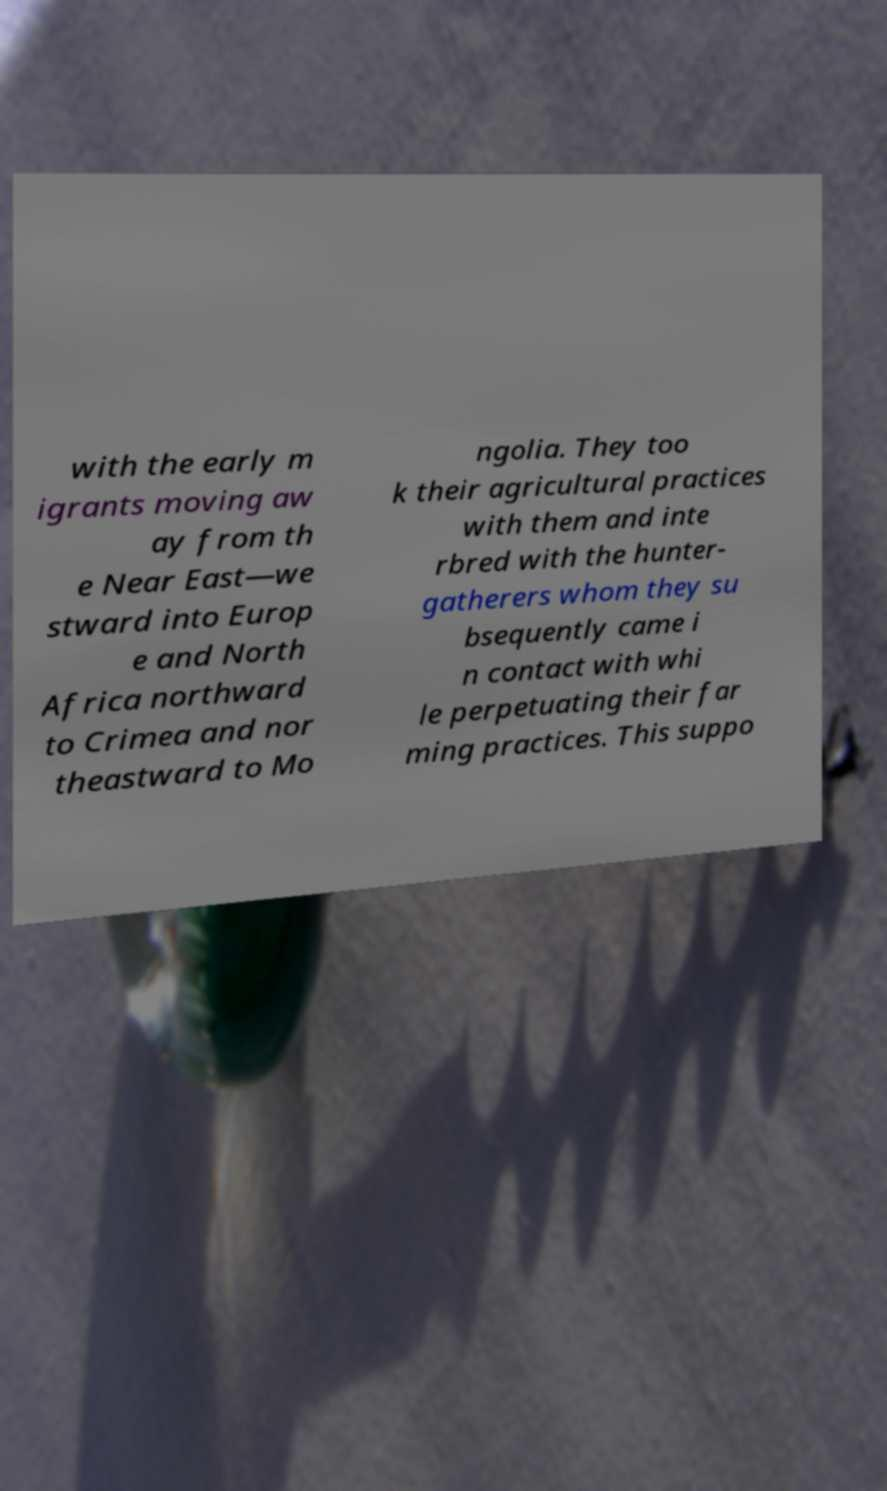Please read and relay the text visible in this image. What does it say? with the early m igrants moving aw ay from th e Near East—we stward into Europ e and North Africa northward to Crimea and nor theastward to Mo ngolia. They too k their agricultural practices with them and inte rbred with the hunter- gatherers whom they su bsequently came i n contact with whi le perpetuating their far ming practices. This suppo 